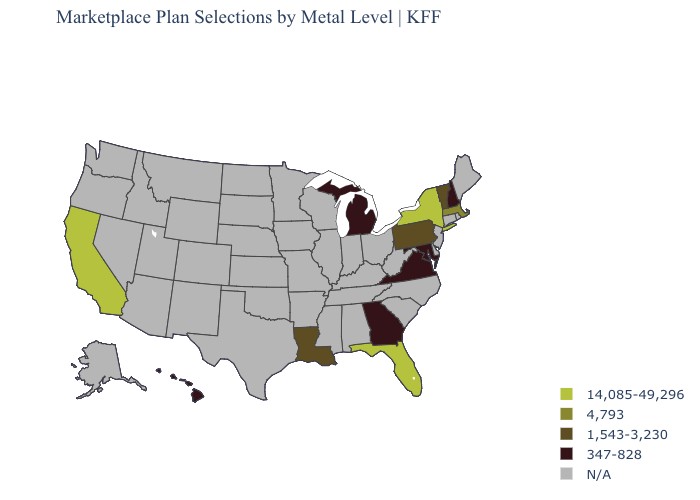What is the value of Kentucky?
Be succinct. N/A. How many symbols are there in the legend?
Short answer required. 5. Does Florida have the highest value in the USA?
Short answer required. Yes. What is the value of Kansas?
Concise answer only. N/A. Name the states that have a value in the range 1,543-3,230?
Give a very brief answer. Louisiana, Pennsylvania, Vermont. What is the value of Massachusetts?
Write a very short answer. 4,793. What is the value of Hawaii?
Give a very brief answer. 347-828. Name the states that have a value in the range 347-828?
Give a very brief answer. Georgia, Hawaii, Maryland, Michigan, New Hampshire, Virginia. What is the value of Ohio?
Concise answer only. N/A. What is the highest value in the USA?
Write a very short answer. 14,085-49,296. Which states have the lowest value in the Northeast?
Be succinct. New Hampshire. What is the lowest value in states that border Maryland?
Answer briefly. 347-828. 